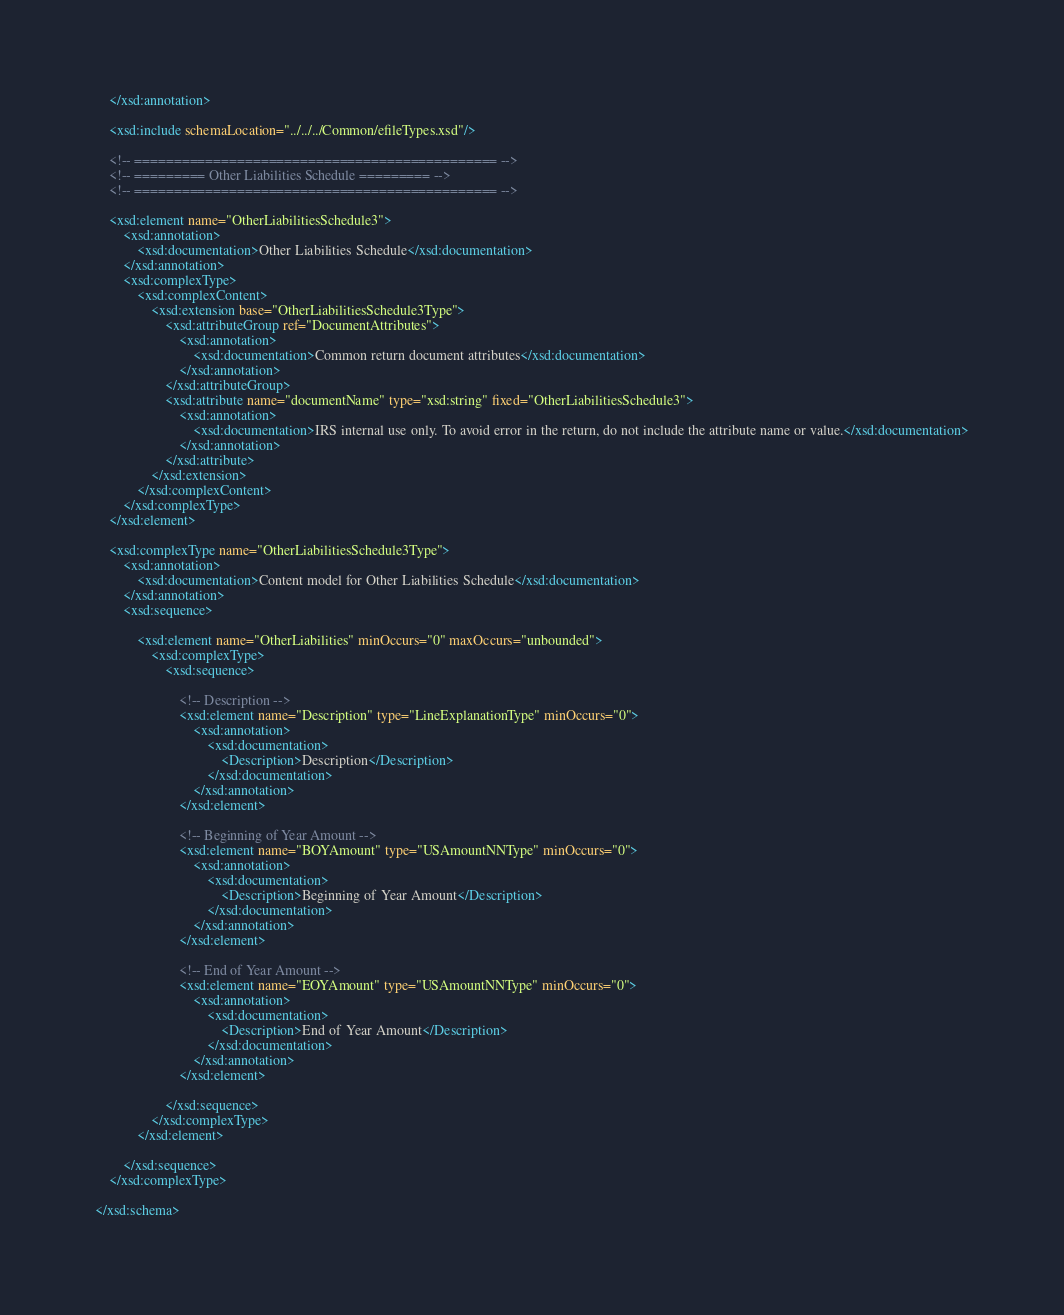<code> <loc_0><loc_0><loc_500><loc_500><_XML_>	</xsd:annotation>
	
	<xsd:include schemaLocation="../../../Common/efileTypes.xsd"/>
	
	<!-- ============================================== -->
	<!-- ========= Other Liabilities Schedule ========= -->
	<!-- ============================================== -->
	
	<xsd:element name="OtherLiabilitiesSchedule3">
		<xsd:annotation>
			<xsd:documentation>Other Liabilities Schedule</xsd:documentation>
		</xsd:annotation>
		<xsd:complexType>
			<xsd:complexContent>
				<xsd:extension base="OtherLiabilitiesSchedule3Type">
					<xsd:attributeGroup ref="DocumentAttributes">
						<xsd:annotation>
							<xsd:documentation>Common return document attributes</xsd:documentation>
						</xsd:annotation>
					</xsd:attributeGroup>
					<xsd:attribute name="documentName" type="xsd:string" fixed="OtherLiabilitiesSchedule3">
						<xsd:annotation>
							<xsd:documentation>IRS internal use only. To avoid error in the return, do not include the attribute name or value.</xsd:documentation>
						</xsd:annotation>
					</xsd:attribute>
				</xsd:extension>
			</xsd:complexContent>
		</xsd:complexType>
	</xsd:element>
	
	<xsd:complexType name="OtherLiabilitiesSchedule3Type">
		<xsd:annotation>
			<xsd:documentation>Content model for Other Liabilities Schedule</xsd:documentation>
		</xsd:annotation>
		<xsd:sequence>

			<xsd:element name="OtherLiabilities" minOccurs="0" maxOccurs="unbounded">
				<xsd:complexType>
					<xsd:sequence>

						<!-- Description -->
						<xsd:element name="Description" type="LineExplanationType" minOccurs="0">
							<xsd:annotation>
								<xsd:documentation>
									<Description>Description</Description>
								</xsd:documentation>
							</xsd:annotation>
						</xsd:element>

						<!-- Beginning of Year Amount -->
						<xsd:element name="BOYAmount" type="USAmountNNType" minOccurs="0">
							<xsd:annotation>
								<xsd:documentation>
									<Description>Beginning of Year Amount</Description>
								</xsd:documentation>
							</xsd:annotation>
						</xsd:element>

						<!-- End of Year Amount -->
						<xsd:element name="EOYAmount" type="USAmountNNType" minOccurs="0">
							<xsd:annotation>
								<xsd:documentation>
									<Description>End of Year Amount</Description>
								</xsd:documentation>
							</xsd:annotation>
						</xsd:element>

					</xsd:sequence>
				</xsd:complexType>
			</xsd:element>

		</xsd:sequence>
	</xsd:complexType>

</xsd:schema>
</code> 